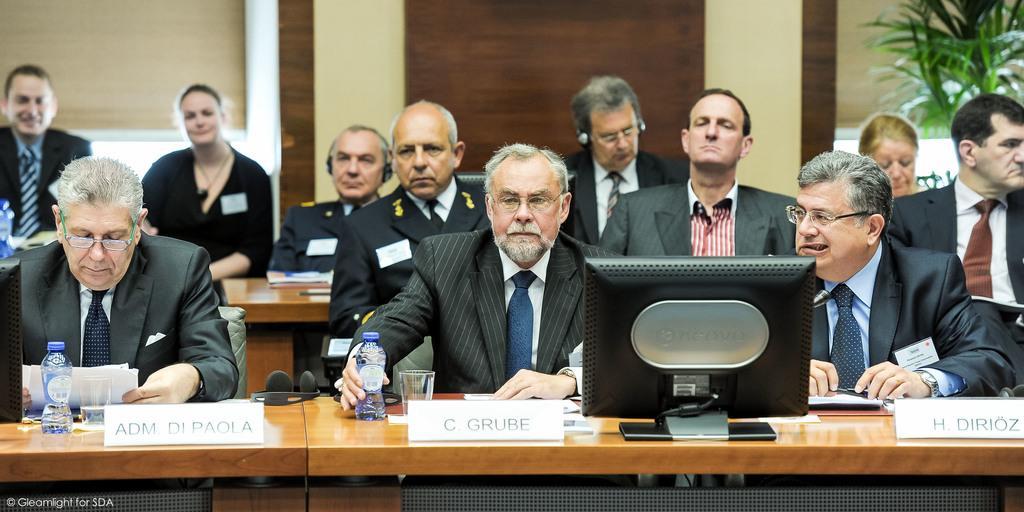How would you summarize this image in a sentence or two? In this picture we can see a group of people sitting on chair and they are in meeting i think in front of them we have table and on table we can see headphones, bottle, glass, monitor and here some persons wore spectacle, blazer, tie and in background we can see wall, tree. 